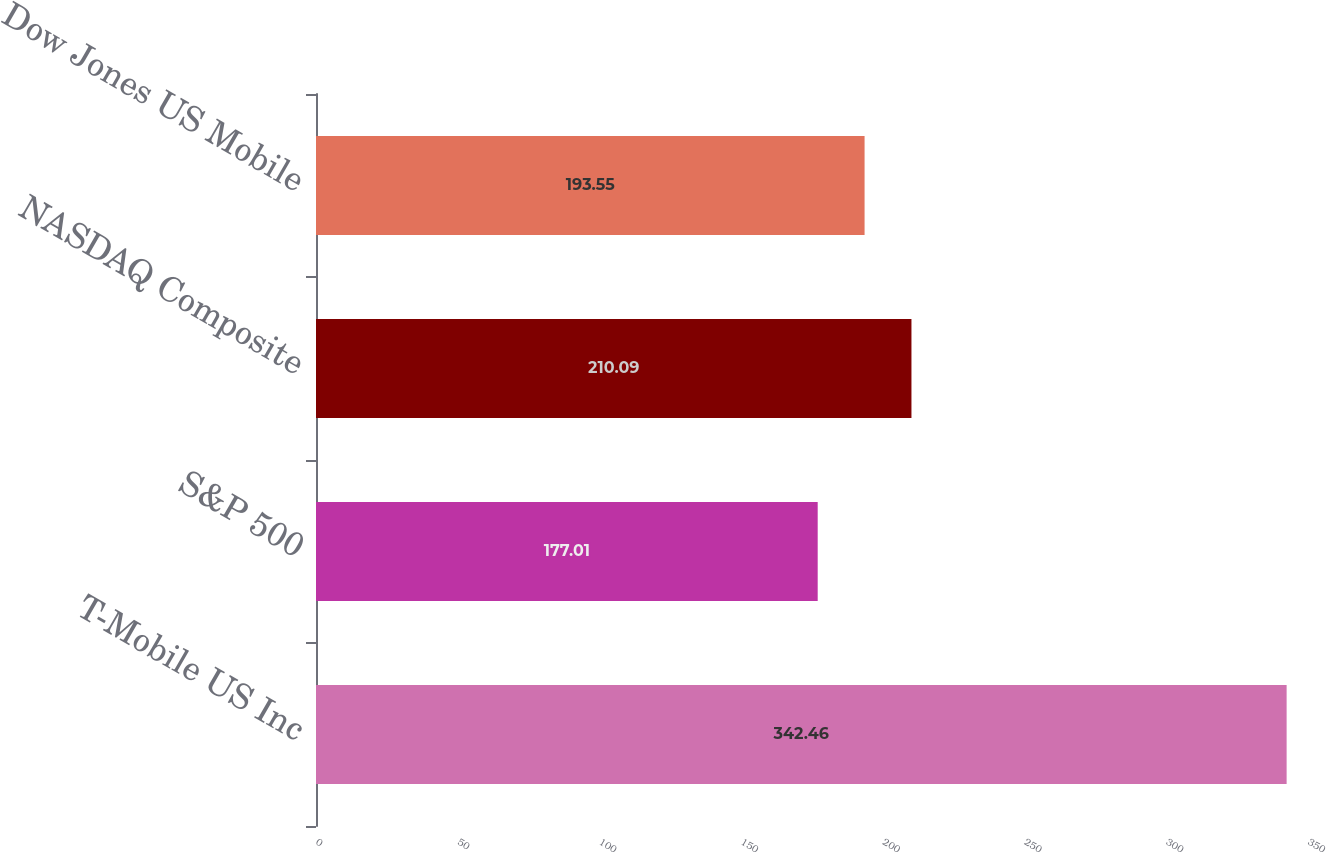<chart> <loc_0><loc_0><loc_500><loc_500><bar_chart><fcel>T-Mobile US Inc<fcel>S&P 500<fcel>NASDAQ Composite<fcel>Dow Jones US Mobile<nl><fcel>342.46<fcel>177.01<fcel>210.09<fcel>193.55<nl></chart> 